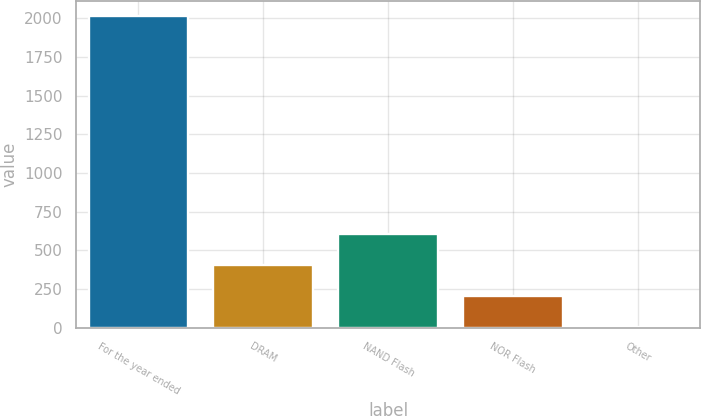<chart> <loc_0><loc_0><loc_500><loc_500><bar_chart><fcel>For the year ended<fcel>DRAM<fcel>NAND Flash<fcel>NOR Flash<fcel>Other<nl><fcel>2012<fcel>406.4<fcel>607.1<fcel>205.7<fcel>5<nl></chart> 